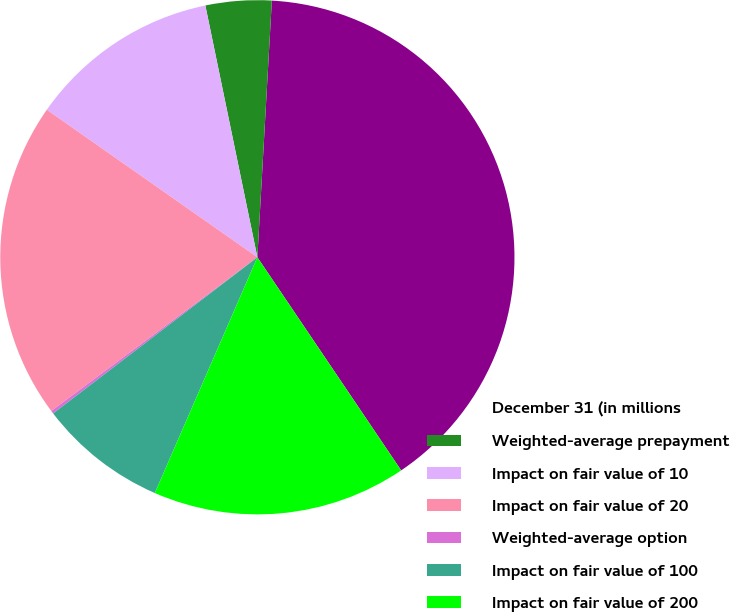<chart> <loc_0><loc_0><loc_500><loc_500><pie_chart><fcel>December 31 (in millions<fcel>Weighted-average prepayment<fcel>Impact on fair value of 10<fcel>Impact on fair value of 20<fcel>Weighted-average option<fcel>Impact on fair value of 100<fcel>Impact on fair value of 200<nl><fcel>39.66%<fcel>4.14%<fcel>12.03%<fcel>19.93%<fcel>0.19%<fcel>8.08%<fcel>15.98%<nl></chart> 